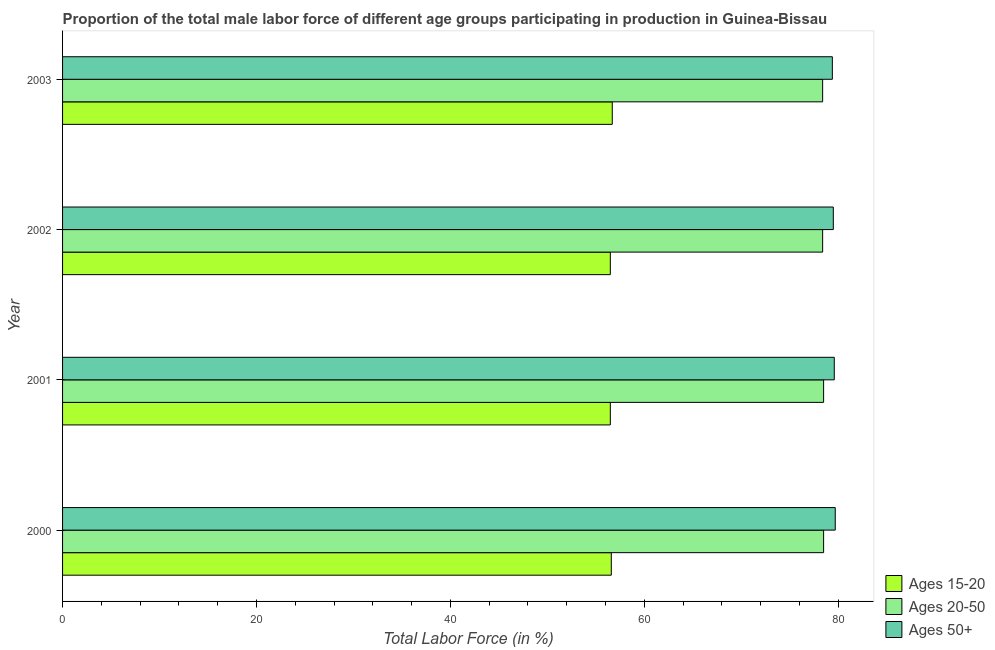How many groups of bars are there?
Ensure brevity in your answer.  4. How many bars are there on the 4th tick from the top?
Your answer should be very brief. 3. In how many cases, is the number of bars for a given year not equal to the number of legend labels?
Your response must be concise. 0. What is the percentage of male labor force above age 50 in 2003?
Keep it short and to the point. 79.4. Across all years, what is the maximum percentage of male labor force within the age group 15-20?
Ensure brevity in your answer.  56.7. Across all years, what is the minimum percentage of male labor force within the age group 15-20?
Give a very brief answer. 56.5. In which year was the percentage of male labor force within the age group 20-50 maximum?
Offer a very short reply. 2000. What is the total percentage of male labor force within the age group 20-50 in the graph?
Make the answer very short. 313.8. What is the difference between the percentage of male labor force within the age group 15-20 in 2000 and that in 2002?
Your answer should be very brief. 0.1. What is the difference between the percentage of male labor force within the age group 20-50 in 2001 and the percentage of male labor force above age 50 in 2003?
Keep it short and to the point. -0.9. What is the average percentage of male labor force within the age group 15-20 per year?
Offer a very short reply. 56.58. In the year 2001, what is the difference between the percentage of male labor force within the age group 15-20 and percentage of male labor force above age 50?
Give a very brief answer. -23.1. In how many years, is the percentage of male labor force within the age group 20-50 greater than 12 %?
Give a very brief answer. 4. What is the ratio of the percentage of male labor force within the age group 15-20 in 2000 to that in 2001?
Ensure brevity in your answer.  1. Is the percentage of male labor force within the age group 20-50 in 2000 less than that in 2002?
Your answer should be compact. No. Is the difference between the percentage of male labor force within the age group 20-50 in 2001 and 2002 greater than the difference between the percentage of male labor force within the age group 15-20 in 2001 and 2002?
Keep it short and to the point. Yes. What is the difference between the highest and the lowest percentage of male labor force above age 50?
Provide a succinct answer. 0.3. Is the sum of the percentage of male labor force within the age group 15-20 in 2000 and 2003 greater than the maximum percentage of male labor force within the age group 20-50 across all years?
Your answer should be very brief. Yes. What does the 3rd bar from the top in 2003 represents?
Your answer should be compact. Ages 15-20. What does the 2nd bar from the bottom in 2001 represents?
Provide a succinct answer. Ages 20-50. How many years are there in the graph?
Your answer should be compact. 4. Does the graph contain any zero values?
Make the answer very short. No. How many legend labels are there?
Provide a short and direct response. 3. How are the legend labels stacked?
Offer a terse response. Vertical. What is the title of the graph?
Provide a short and direct response. Proportion of the total male labor force of different age groups participating in production in Guinea-Bissau. What is the label or title of the X-axis?
Your response must be concise. Total Labor Force (in %). What is the label or title of the Y-axis?
Make the answer very short. Year. What is the Total Labor Force (in %) of Ages 15-20 in 2000?
Offer a terse response. 56.6. What is the Total Labor Force (in %) of Ages 20-50 in 2000?
Ensure brevity in your answer.  78.5. What is the Total Labor Force (in %) in Ages 50+ in 2000?
Give a very brief answer. 79.7. What is the Total Labor Force (in %) of Ages 15-20 in 2001?
Your answer should be very brief. 56.5. What is the Total Labor Force (in %) of Ages 20-50 in 2001?
Give a very brief answer. 78.5. What is the Total Labor Force (in %) in Ages 50+ in 2001?
Ensure brevity in your answer.  79.6. What is the Total Labor Force (in %) of Ages 15-20 in 2002?
Offer a terse response. 56.5. What is the Total Labor Force (in %) of Ages 20-50 in 2002?
Your answer should be very brief. 78.4. What is the Total Labor Force (in %) in Ages 50+ in 2002?
Your response must be concise. 79.5. What is the Total Labor Force (in %) in Ages 15-20 in 2003?
Keep it short and to the point. 56.7. What is the Total Labor Force (in %) in Ages 20-50 in 2003?
Make the answer very short. 78.4. What is the Total Labor Force (in %) of Ages 50+ in 2003?
Offer a very short reply. 79.4. Across all years, what is the maximum Total Labor Force (in %) in Ages 15-20?
Provide a succinct answer. 56.7. Across all years, what is the maximum Total Labor Force (in %) of Ages 20-50?
Your response must be concise. 78.5. Across all years, what is the maximum Total Labor Force (in %) in Ages 50+?
Provide a succinct answer. 79.7. Across all years, what is the minimum Total Labor Force (in %) in Ages 15-20?
Provide a succinct answer. 56.5. Across all years, what is the minimum Total Labor Force (in %) in Ages 20-50?
Your answer should be compact. 78.4. Across all years, what is the minimum Total Labor Force (in %) of Ages 50+?
Offer a terse response. 79.4. What is the total Total Labor Force (in %) of Ages 15-20 in the graph?
Make the answer very short. 226.3. What is the total Total Labor Force (in %) in Ages 20-50 in the graph?
Keep it short and to the point. 313.8. What is the total Total Labor Force (in %) in Ages 50+ in the graph?
Your answer should be compact. 318.2. What is the difference between the Total Labor Force (in %) in Ages 15-20 in 2000 and that in 2001?
Offer a terse response. 0.1. What is the difference between the Total Labor Force (in %) in Ages 20-50 in 2000 and that in 2001?
Make the answer very short. 0. What is the difference between the Total Labor Force (in %) in Ages 50+ in 2000 and that in 2001?
Ensure brevity in your answer.  0.1. What is the difference between the Total Labor Force (in %) in Ages 20-50 in 2000 and that in 2002?
Provide a succinct answer. 0.1. What is the difference between the Total Labor Force (in %) of Ages 50+ in 2000 and that in 2002?
Provide a short and direct response. 0.2. What is the difference between the Total Labor Force (in %) in Ages 15-20 in 2000 and that in 2003?
Give a very brief answer. -0.1. What is the difference between the Total Labor Force (in %) of Ages 20-50 in 2001 and that in 2002?
Offer a terse response. 0.1. What is the difference between the Total Labor Force (in %) of Ages 50+ in 2001 and that in 2002?
Your answer should be compact. 0.1. What is the difference between the Total Labor Force (in %) in Ages 15-20 in 2001 and that in 2003?
Make the answer very short. -0.2. What is the difference between the Total Labor Force (in %) in Ages 20-50 in 2002 and that in 2003?
Ensure brevity in your answer.  0. What is the difference between the Total Labor Force (in %) in Ages 15-20 in 2000 and the Total Labor Force (in %) in Ages 20-50 in 2001?
Ensure brevity in your answer.  -21.9. What is the difference between the Total Labor Force (in %) of Ages 15-20 in 2000 and the Total Labor Force (in %) of Ages 50+ in 2001?
Offer a terse response. -23. What is the difference between the Total Labor Force (in %) of Ages 15-20 in 2000 and the Total Labor Force (in %) of Ages 20-50 in 2002?
Make the answer very short. -21.8. What is the difference between the Total Labor Force (in %) in Ages 15-20 in 2000 and the Total Labor Force (in %) in Ages 50+ in 2002?
Your answer should be very brief. -22.9. What is the difference between the Total Labor Force (in %) of Ages 20-50 in 2000 and the Total Labor Force (in %) of Ages 50+ in 2002?
Offer a very short reply. -1. What is the difference between the Total Labor Force (in %) in Ages 15-20 in 2000 and the Total Labor Force (in %) in Ages 20-50 in 2003?
Make the answer very short. -21.8. What is the difference between the Total Labor Force (in %) of Ages 15-20 in 2000 and the Total Labor Force (in %) of Ages 50+ in 2003?
Offer a terse response. -22.8. What is the difference between the Total Labor Force (in %) of Ages 20-50 in 2000 and the Total Labor Force (in %) of Ages 50+ in 2003?
Give a very brief answer. -0.9. What is the difference between the Total Labor Force (in %) of Ages 15-20 in 2001 and the Total Labor Force (in %) of Ages 20-50 in 2002?
Offer a very short reply. -21.9. What is the difference between the Total Labor Force (in %) in Ages 15-20 in 2001 and the Total Labor Force (in %) in Ages 50+ in 2002?
Give a very brief answer. -23. What is the difference between the Total Labor Force (in %) in Ages 20-50 in 2001 and the Total Labor Force (in %) in Ages 50+ in 2002?
Your response must be concise. -1. What is the difference between the Total Labor Force (in %) of Ages 15-20 in 2001 and the Total Labor Force (in %) of Ages 20-50 in 2003?
Make the answer very short. -21.9. What is the difference between the Total Labor Force (in %) of Ages 15-20 in 2001 and the Total Labor Force (in %) of Ages 50+ in 2003?
Ensure brevity in your answer.  -22.9. What is the difference between the Total Labor Force (in %) in Ages 20-50 in 2001 and the Total Labor Force (in %) in Ages 50+ in 2003?
Offer a terse response. -0.9. What is the difference between the Total Labor Force (in %) of Ages 15-20 in 2002 and the Total Labor Force (in %) of Ages 20-50 in 2003?
Provide a short and direct response. -21.9. What is the difference between the Total Labor Force (in %) in Ages 15-20 in 2002 and the Total Labor Force (in %) in Ages 50+ in 2003?
Keep it short and to the point. -22.9. What is the average Total Labor Force (in %) of Ages 15-20 per year?
Your answer should be compact. 56.58. What is the average Total Labor Force (in %) of Ages 20-50 per year?
Ensure brevity in your answer.  78.45. What is the average Total Labor Force (in %) of Ages 50+ per year?
Make the answer very short. 79.55. In the year 2000, what is the difference between the Total Labor Force (in %) of Ages 15-20 and Total Labor Force (in %) of Ages 20-50?
Your response must be concise. -21.9. In the year 2000, what is the difference between the Total Labor Force (in %) in Ages 15-20 and Total Labor Force (in %) in Ages 50+?
Provide a succinct answer. -23.1. In the year 2001, what is the difference between the Total Labor Force (in %) in Ages 15-20 and Total Labor Force (in %) in Ages 20-50?
Offer a terse response. -22. In the year 2001, what is the difference between the Total Labor Force (in %) in Ages 15-20 and Total Labor Force (in %) in Ages 50+?
Ensure brevity in your answer.  -23.1. In the year 2002, what is the difference between the Total Labor Force (in %) in Ages 15-20 and Total Labor Force (in %) in Ages 20-50?
Provide a succinct answer. -21.9. In the year 2002, what is the difference between the Total Labor Force (in %) in Ages 15-20 and Total Labor Force (in %) in Ages 50+?
Make the answer very short. -23. In the year 2002, what is the difference between the Total Labor Force (in %) in Ages 20-50 and Total Labor Force (in %) in Ages 50+?
Provide a succinct answer. -1.1. In the year 2003, what is the difference between the Total Labor Force (in %) in Ages 15-20 and Total Labor Force (in %) in Ages 20-50?
Your answer should be compact. -21.7. In the year 2003, what is the difference between the Total Labor Force (in %) in Ages 15-20 and Total Labor Force (in %) in Ages 50+?
Offer a very short reply. -22.7. In the year 2003, what is the difference between the Total Labor Force (in %) of Ages 20-50 and Total Labor Force (in %) of Ages 50+?
Provide a short and direct response. -1. What is the ratio of the Total Labor Force (in %) in Ages 20-50 in 2000 to that in 2001?
Offer a very short reply. 1. What is the ratio of the Total Labor Force (in %) in Ages 50+ in 2000 to that in 2001?
Give a very brief answer. 1. What is the ratio of the Total Labor Force (in %) in Ages 15-20 in 2000 to that in 2002?
Keep it short and to the point. 1. What is the ratio of the Total Labor Force (in %) in Ages 20-50 in 2000 to that in 2002?
Keep it short and to the point. 1. What is the ratio of the Total Labor Force (in %) of Ages 15-20 in 2000 to that in 2003?
Provide a succinct answer. 1. What is the ratio of the Total Labor Force (in %) in Ages 20-50 in 2000 to that in 2003?
Keep it short and to the point. 1. What is the ratio of the Total Labor Force (in %) in Ages 20-50 in 2001 to that in 2002?
Make the answer very short. 1. What is the ratio of the Total Labor Force (in %) in Ages 15-20 in 2002 to that in 2003?
Provide a short and direct response. 1. What is the ratio of the Total Labor Force (in %) in Ages 50+ in 2002 to that in 2003?
Keep it short and to the point. 1. What is the difference between the highest and the second highest Total Labor Force (in %) of Ages 15-20?
Make the answer very short. 0.1. What is the difference between the highest and the second highest Total Labor Force (in %) in Ages 20-50?
Offer a very short reply. 0. What is the difference between the highest and the lowest Total Labor Force (in %) of Ages 20-50?
Keep it short and to the point. 0.1. What is the difference between the highest and the lowest Total Labor Force (in %) in Ages 50+?
Your response must be concise. 0.3. 